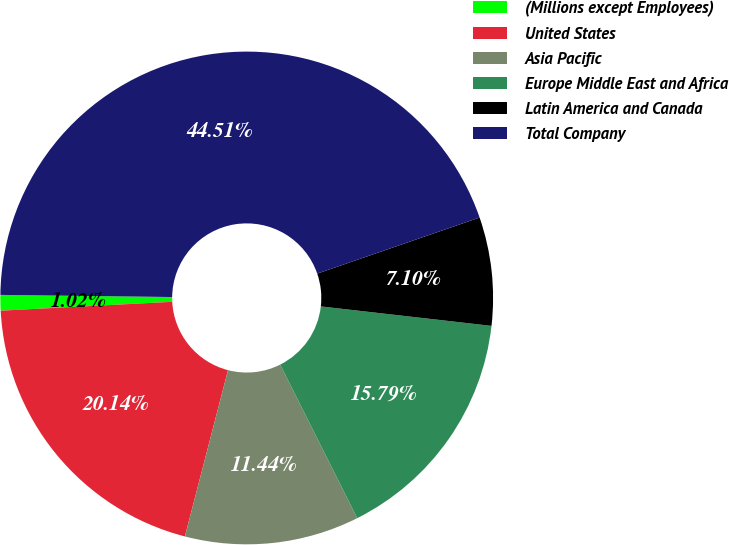<chart> <loc_0><loc_0><loc_500><loc_500><pie_chart><fcel>(Millions except Employees)<fcel>United States<fcel>Asia Pacific<fcel>Europe Middle East and Africa<fcel>Latin America and Canada<fcel>Total Company<nl><fcel>1.02%<fcel>20.14%<fcel>11.44%<fcel>15.79%<fcel>7.1%<fcel>44.51%<nl></chart> 